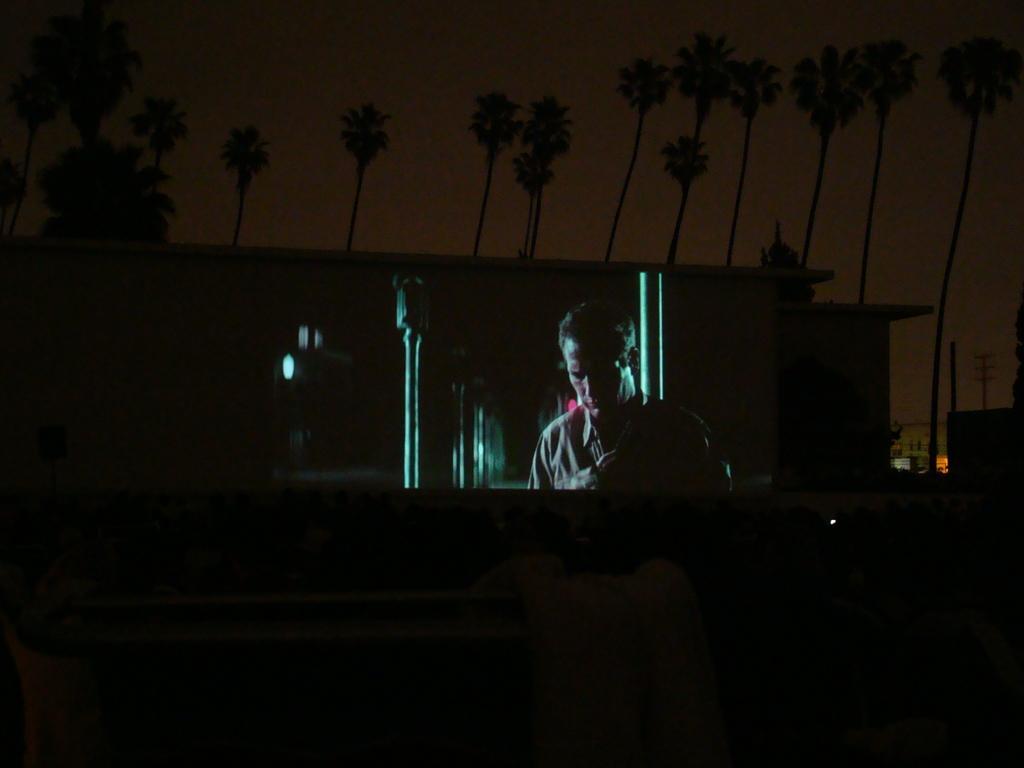Can you describe this image briefly? In this picture we can see a person. There is a white object at the bottom. We can see a few lights, buildings and trees in the background. 